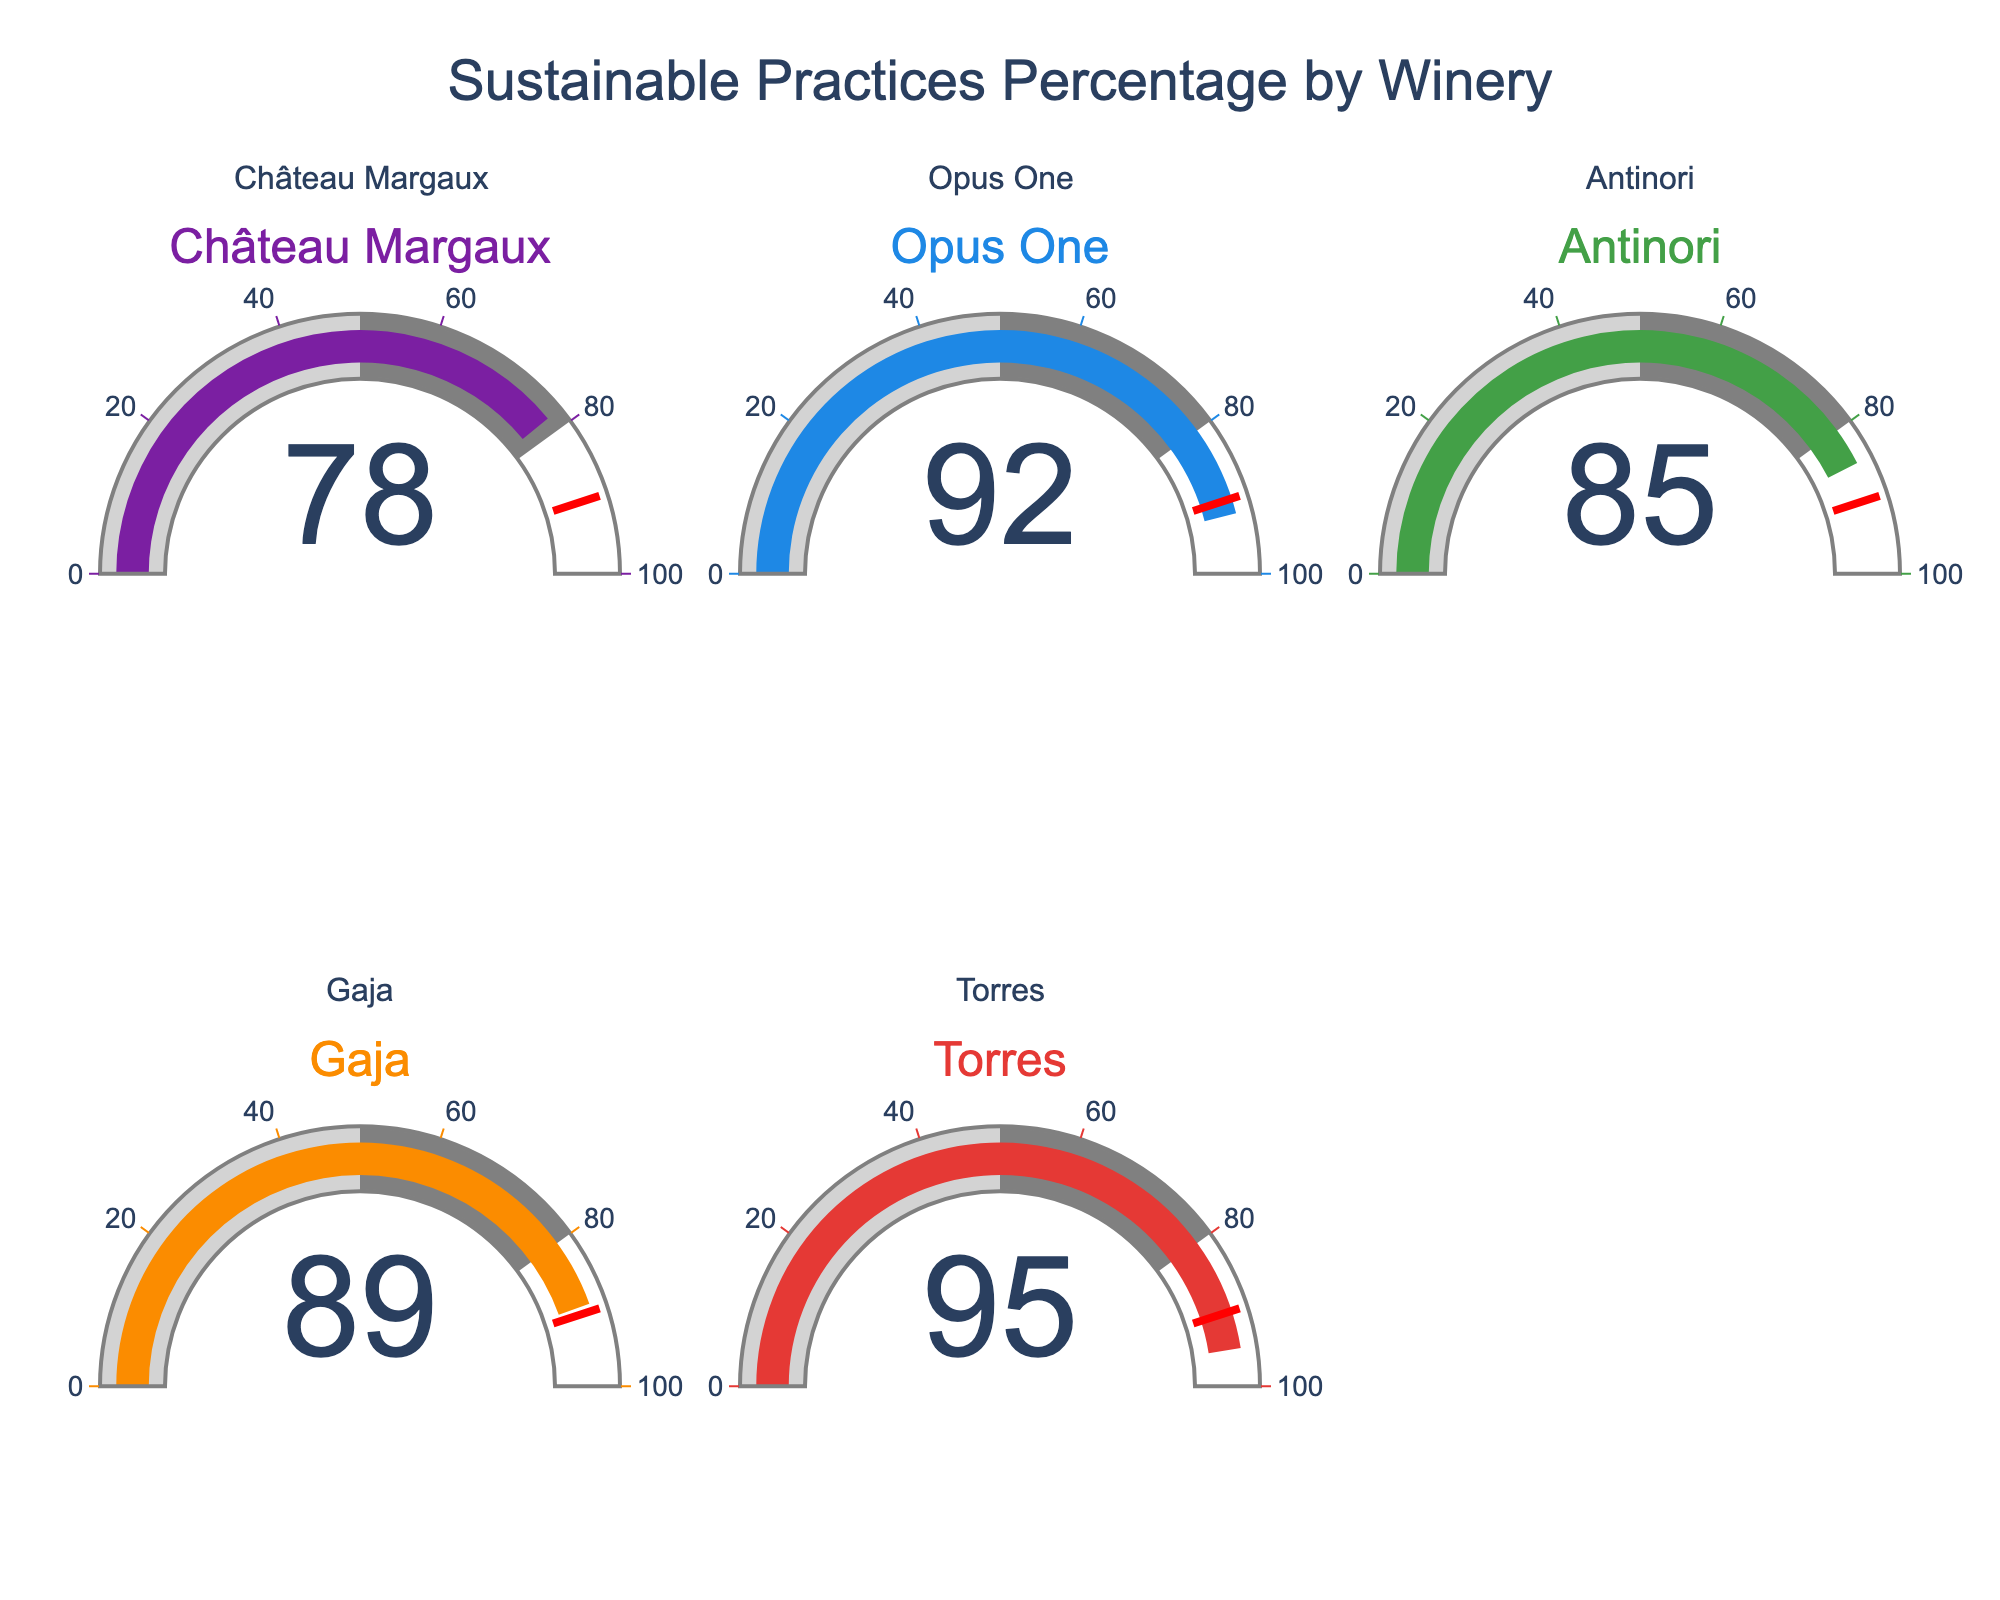What's the title of the chart? The title of the chart is typically displayed at the top center of the figure. In this figure, it reads "Sustainable Practices Percentage by Winery".
Answer: Sustainable Practices Percentage by Winery What percentage of wine production at Torres uses sustainable practices? The chart features five gauges, each representing a winery's percentage of sustainable practices. The gauge for Torres shows a value of 95%.
Answer: 95% Which winery has the lowest percentage of sustainable practices? To find the lowest percentage, compare the values on each gauge. Château Margaux shows 78%, Opus One has 92%, Antinori is at 85%, Gaja shows 89%, and Torres has 95%. The lowest value is 78% from Château Margaux.
Answer: Château Margaux What is the average percentage of sustainable practices across all five wineries? First, add the percentages: 78, 92, 85, 89, and 95. The sum is 439. Now, divide by the number of wineries (5), resulting in 439/5 = 87.8%.
Answer: 87.8% By how much does the percentage of sustainable practices at Opus One exceed that at Antinori? The percentage for Opus One is 92%, and for Antinori, it is 85%. Subtract the two percentages: 92 - 85 = 7.
Answer: 7% Has any winery reached or surpassed the 90% threshold mentioned in the figure? Various percentages can be seen on the gauges: Château Margaux (78%), Opus One (92%), Antinori (85%), Gaja (89%), and Torres (95%). Both Opus One and Torres have percentages equal to or above 90%.
Answer: Yes What is the median percentage of sustainable practices among the five wineries? List the percentages in ascending order: 78%, 85%, 89%, 92%, 95%. The median value is the middle number, which is 89%.
Answer: 89% Compare the sustainable practices percentages between Gaja and Antinori. Who has a higher percentage? The values for Gaja and Antinori are 89% and 85%, respectively. Since 89% is greater than 85%, Gaja has a higher percentage.
Answer: Gaja Which winery is closest to reaching the 100% mark for sustainable practices? Looking at the percentages: Château Margaux (78%), Opus One (92%), Antinori (85%), Gaja (89%), and Torres (95%). The winery with the highest percentage is Torres at 95%, making it closest to 100%.
Answer: Torres What is the range of sustainable practices percentages among the wineries? To find the range, subtract the lowest percentage from the highest. The lowest is 78% (Château Margaux), and the highest is 95% (Torres). The range is 95 - 78 = 17.
Answer: 17 